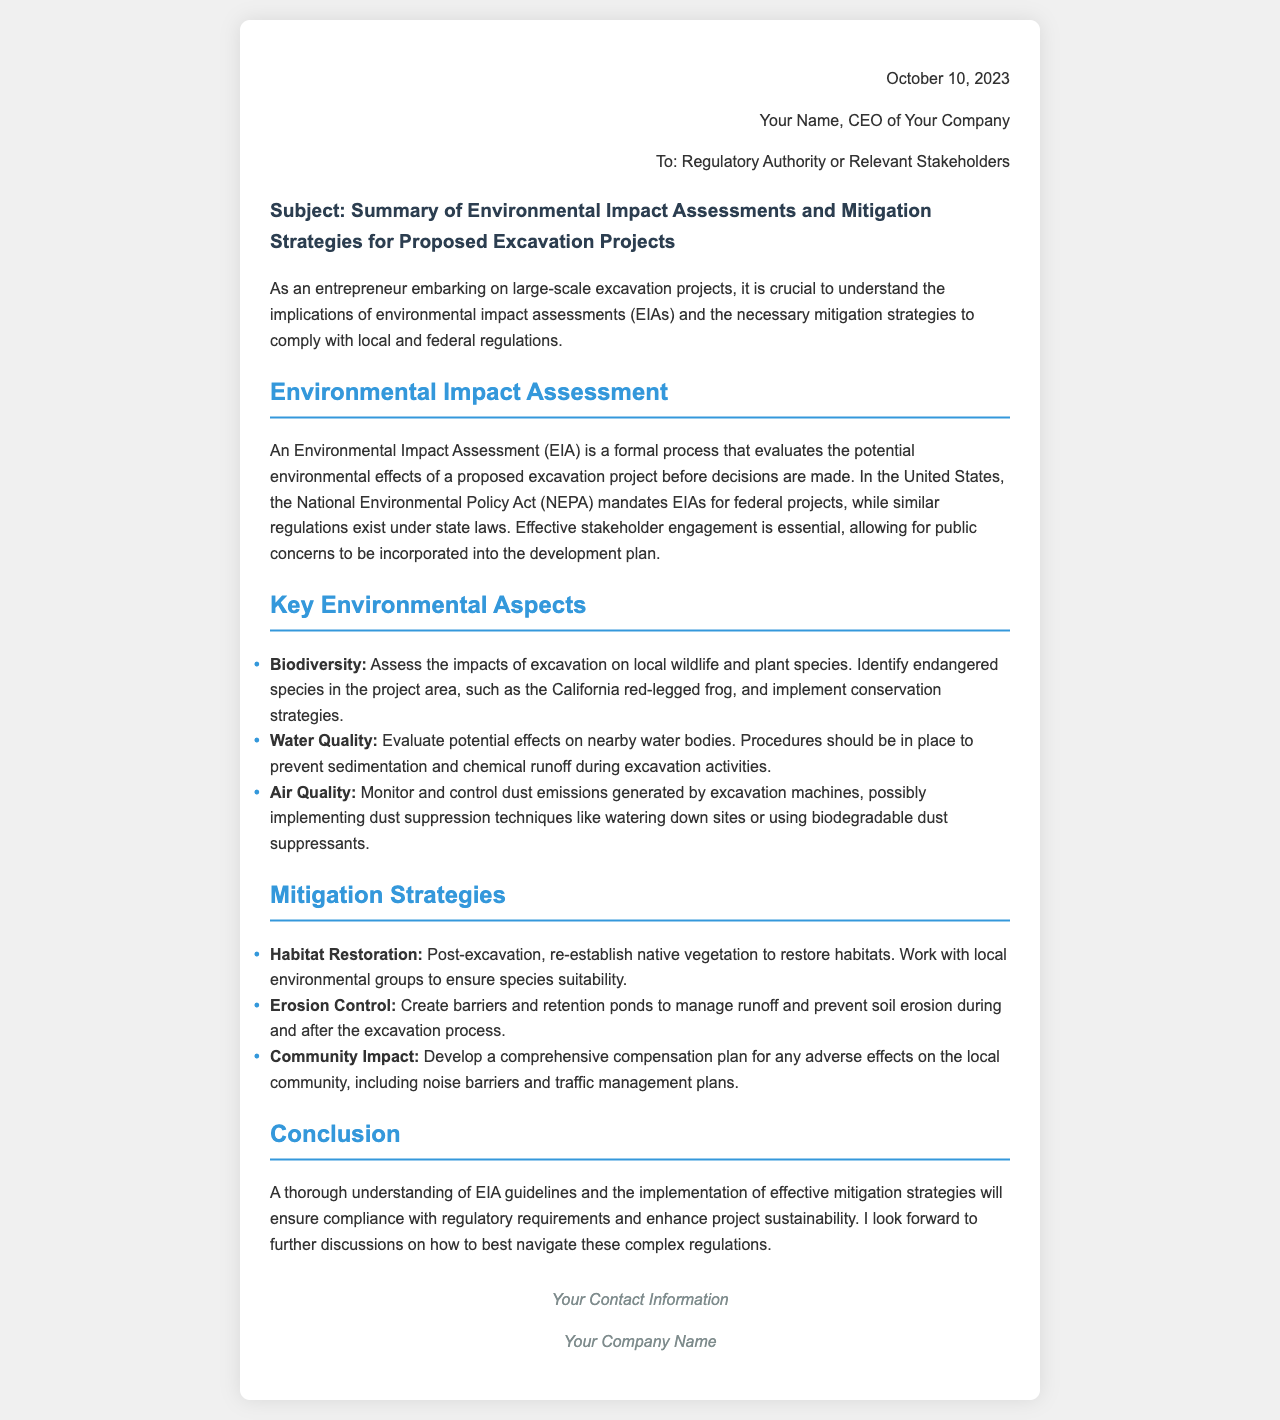what is the date of the letter? The date of the letter is mentioned at the beginning of the document, which is October 10, 2023.
Answer: October 10, 2023 who is the author of the letter? The author of the letter is referred to as Your Name, CEO of Your Company.
Answer: Your Name what is the main subject of the letter? The subject of the letter indicates the focus on environmental assessments and mitigation strategies for excavation projects.
Answer: Summary of Environmental Impact Assessments and Mitigation Strategies for Proposed Excavation Projects what federal act mandates Environmental Impact Assessments (EIAs)? The document states that the National Environmental Policy Act (NEPA) mandates EIAs for federal projects.
Answer: National Environmental Policy Act (NEPA) which endangered species is mentioned in the document? The document lists the California red-legged frog as an endangered species to be considered in the project area.
Answer: California red-legged frog what is one mitigation strategy for habitat restoration? A strategy mentioned for habitat restoration is to re-establish native vegetation after excavation.
Answer: Re-establish native vegetation how should air quality be monitored according to the document? The document suggests controlling dust emissions from excavation machines using techniques like watering down sites.
Answer: Dust suppression techniques what should be included in a comprehensive compensation plan? The document highlights that a compensation plan should address noise barriers and traffic management plans for the local community.
Answer: Noise barriers and traffic management plans what is essential for effective stakeholder engagement? The document emphasizes the importance of incorporating public concerns into the development plan during stakeholders' engagement.
Answer: Incorporating public concerns 